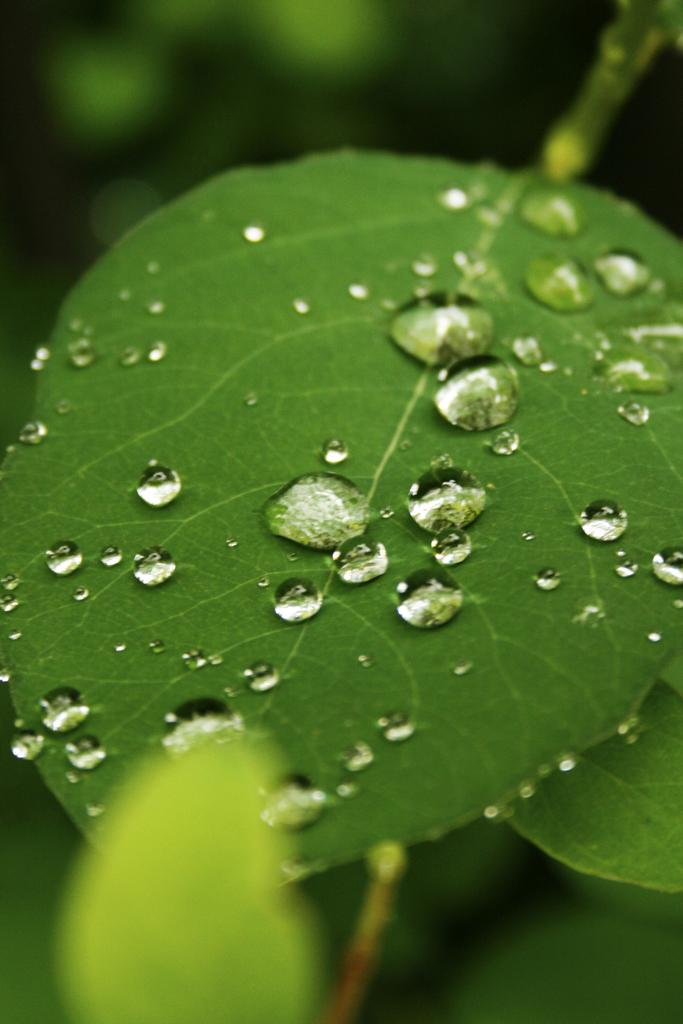What is present in the image? There is a leaf in the image. What can be observed on the leaf? The leaf has water drops on it. What time is displayed on the quartz clock in the image? There is no quartz clock present in the image; it only features a leaf with water drops on it. 